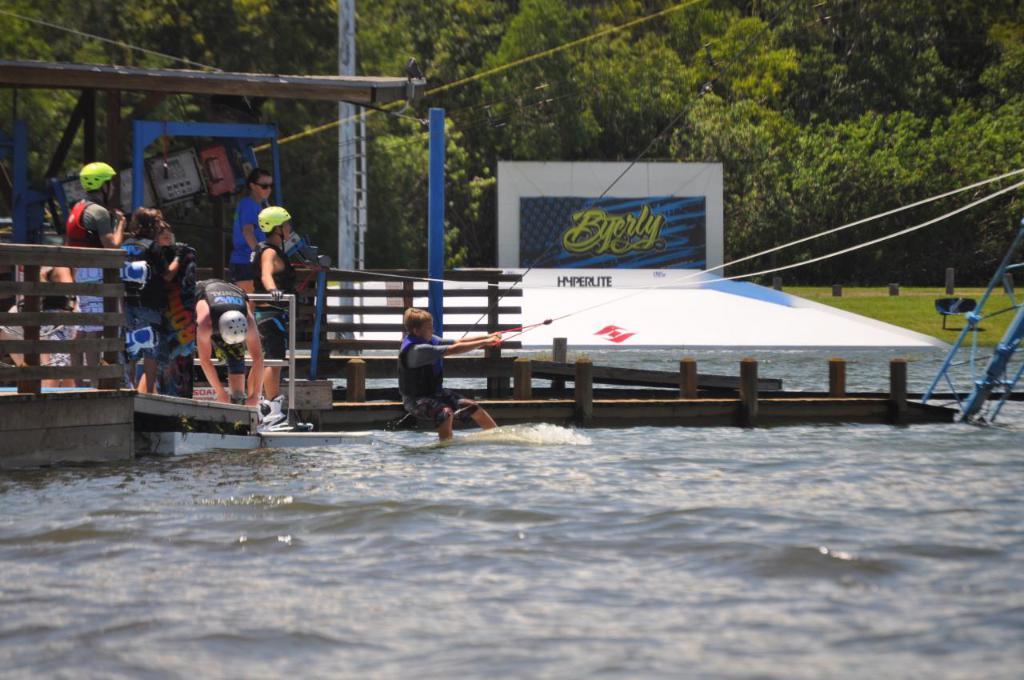What brand is displayed on the ramp?
Offer a terse response. Byerly. 